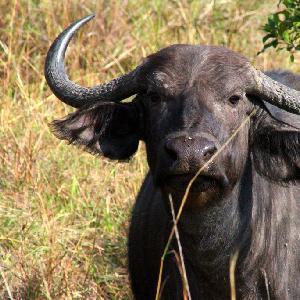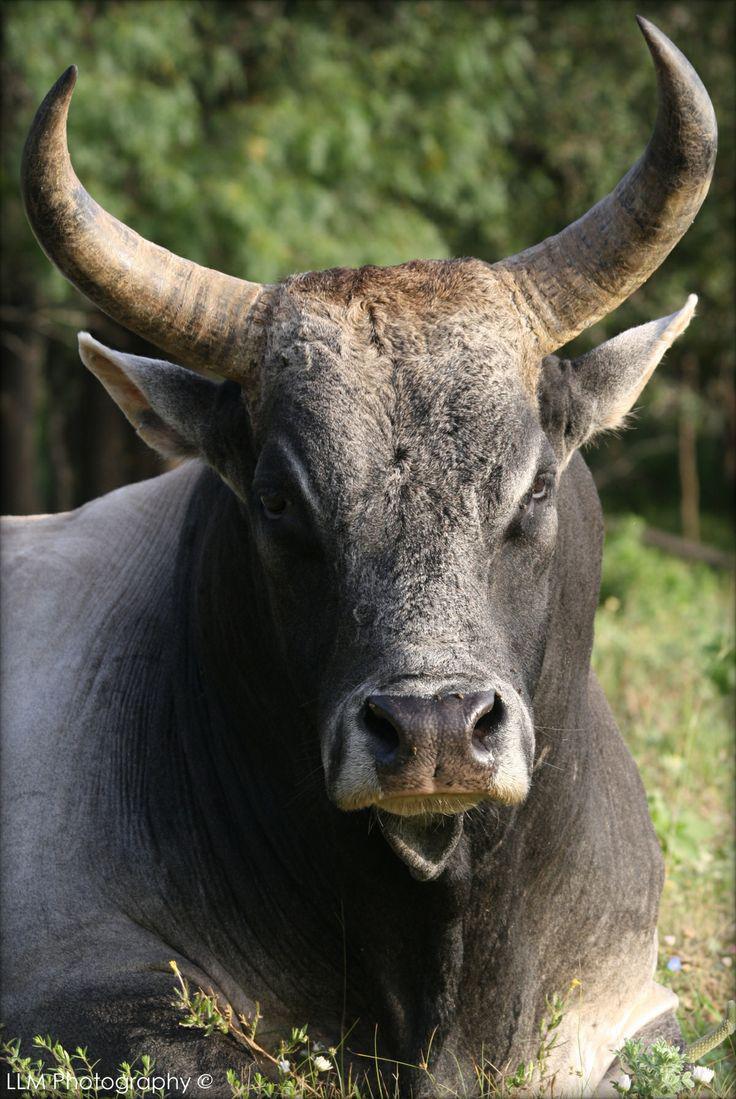The first image is the image on the left, the second image is the image on the right. Evaluate the accuracy of this statement regarding the images: "One of the images contains more than one water buffalo.". Is it true? Answer yes or no. No. 